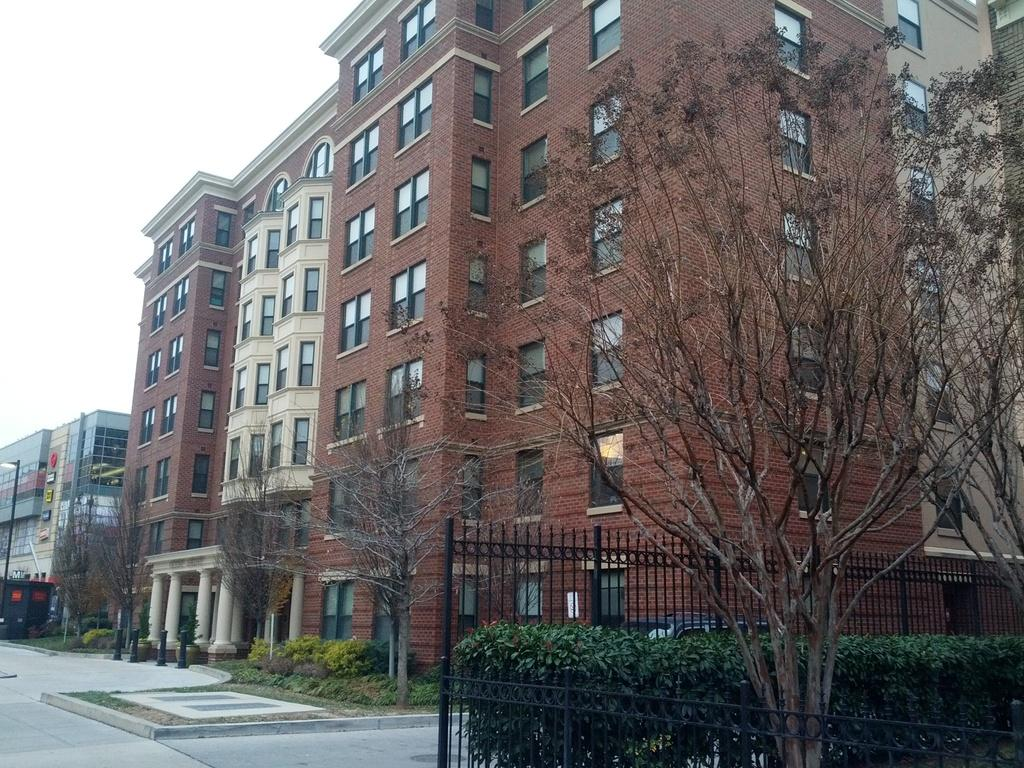What type of structures are present in the image? There is a group of buildings in the image. What type of vegetation can be seen in the image? There are trees and plants in the image. What type of barrier is present in the image? There is fencing in the image. What part of the natural environment is visible in the image? The sky is visible in the top left corner of the image. Can you describe the pain that the rabbit is experiencing in the image? There is no rabbit present in the image, so it is not possible to describe any pain it might be experiencing. 